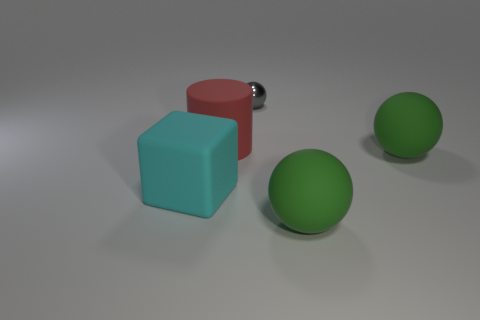Add 1 small metal cubes. How many objects exist? 6 Subtract all balls. How many objects are left? 2 Add 5 matte balls. How many matte balls are left? 7 Add 5 cubes. How many cubes exist? 6 Subtract 0 brown cylinders. How many objects are left? 5 Subtract all small metal cubes. Subtract all green spheres. How many objects are left? 3 